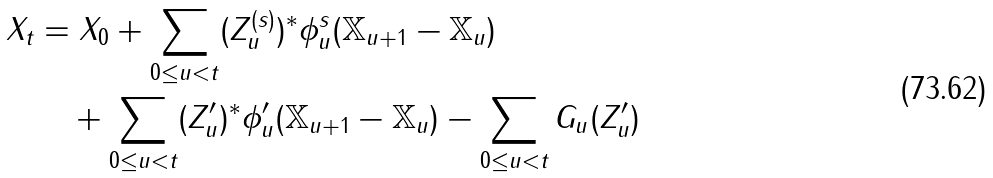Convert formula to latex. <formula><loc_0><loc_0><loc_500><loc_500>X _ { t } & = X _ { 0 } + \sum _ { 0 \leq u < t } ( Z _ { u } ^ { ( s ) } ) ^ { * } \phi ^ { s } _ { u } ( \mathbb { X } _ { u + 1 } - \mathbb { X } _ { u } ) \\ & \quad + \sum _ { 0 \leq u < t } ( Z _ { u } ^ { \prime } ) ^ { * } \phi ^ { \prime } _ { u } ( \mathbb { X } _ { u + 1 } - \mathbb { X } _ { u } ) - \sum _ { 0 \leq u < t } G _ { u } ( Z _ { u } ^ { \prime } )</formula> 